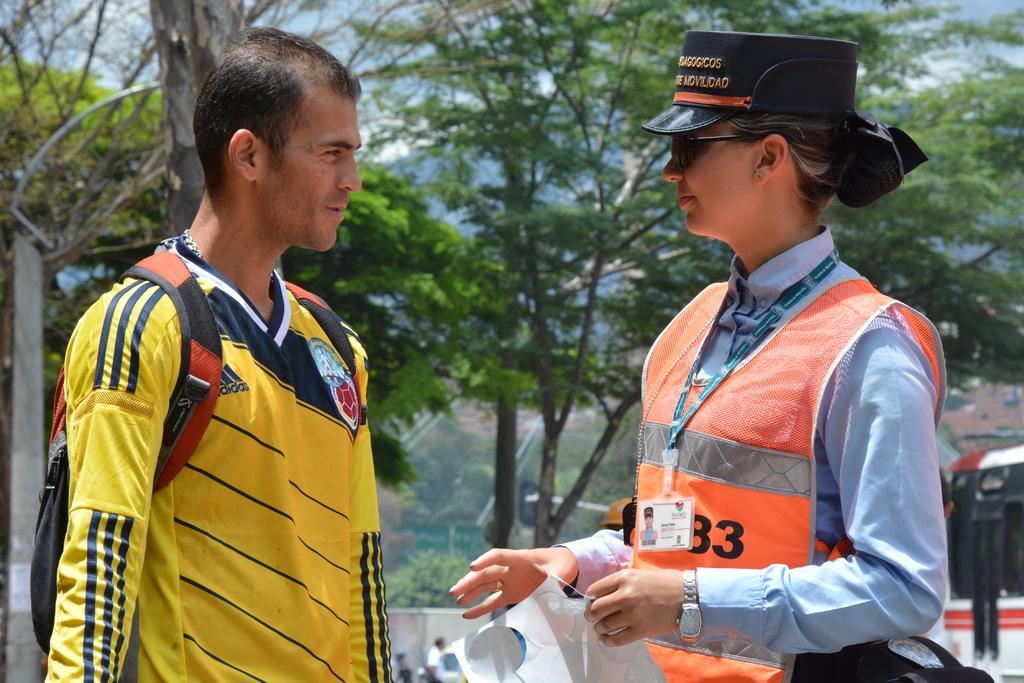Please provide a concise description of this image. On the left side, there is a person in a yellow color t-shirt, smiling and standing. On the right side, there is a woman in an orange color jacket, wearing a badge and a black color cap, smiling and holding an object. In the background, there is a vehicle, there are trees, persons, mountains and there are clouds in the sky. 